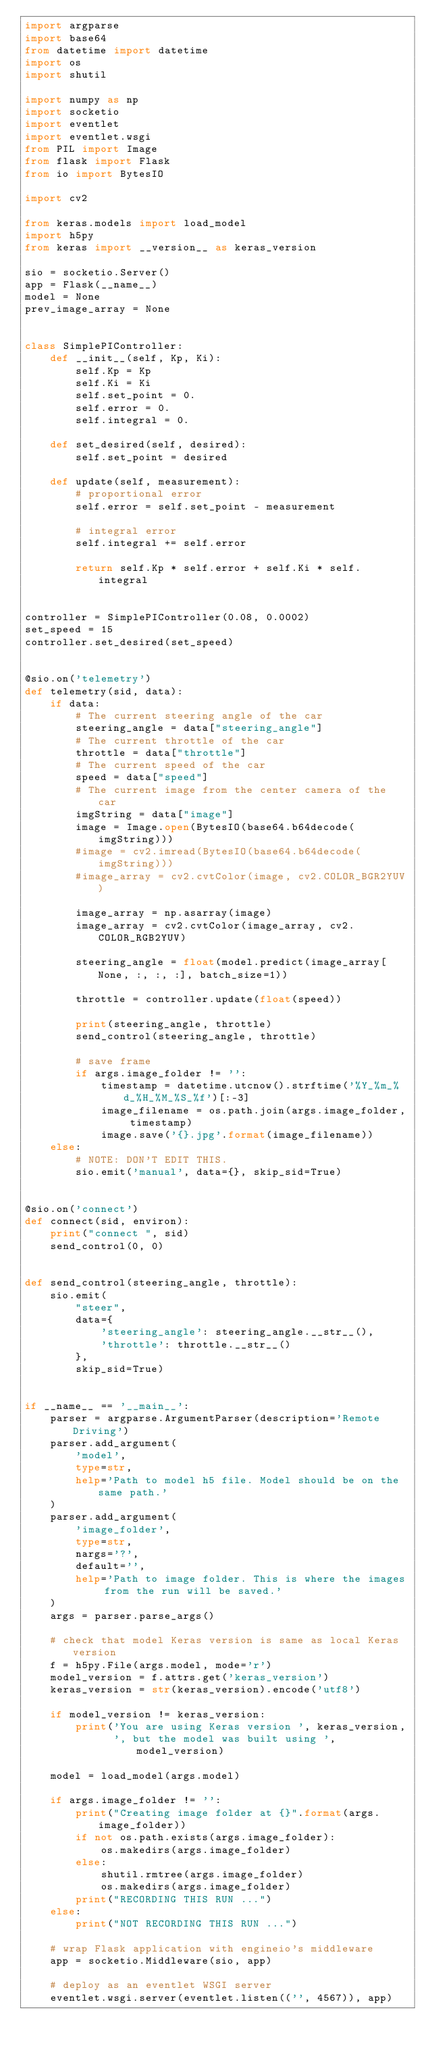<code> <loc_0><loc_0><loc_500><loc_500><_Python_>import argparse
import base64
from datetime import datetime
import os
import shutil

import numpy as np
import socketio
import eventlet
import eventlet.wsgi
from PIL import Image
from flask import Flask
from io import BytesIO

import cv2

from keras.models import load_model
import h5py
from keras import __version__ as keras_version

sio = socketio.Server()
app = Flask(__name__)
model = None
prev_image_array = None


class SimplePIController:
    def __init__(self, Kp, Ki):
        self.Kp = Kp
        self.Ki = Ki
        self.set_point = 0.
        self.error = 0.
        self.integral = 0.

    def set_desired(self, desired):
        self.set_point = desired

    def update(self, measurement):
        # proportional error
        self.error = self.set_point - measurement

        # integral error
        self.integral += self.error

        return self.Kp * self.error + self.Ki * self.integral


controller = SimplePIController(0.08, 0.0002)
set_speed = 15
controller.set_desired(set_speed)


@sio.on('telemetry')
def telemetry(sid, data):
    if data:
        # The current steering angle of the car
        steering_angle = data["steering_angle"]
        # The current throttle of the car
        throttle = data["throttle"]
        # The current speed of the car
        speed = data["speed"]
        # The current image from the center camera of the car
        imgString = data["image"]
        image = Image.open(BytesIO(base64.b64decode(imgString)))
        #image = cv2.imread(BytesIO(base64.b64decode(imgString)))
        #image_array = cv2.cvtColor(image, cv2.COLOR_BGR2YUV)

        image_array = np.asarray(image)
        image_array = cv2.cvtColor(image_array, cv2.COLOR_RGB2YUV)

        steering_angle = float(model.predict(image_array[None, :, :, :], batch_size=1))

        throttle = controller.update(float(speed))

        print(steering_angle, throttle)
        send_control(steering_angle, throttle)

        # save frame
        if args.image_folder != '':
            timestamp = datetime.utcnow().strftime('%Y_%m_%d_%H_%M_%S_%f')[:-3]
            image_filename = os.path.join(args.image_folder, timestamp)
            image.save('{}.jpg'.format(image_filename))
    else:
        # NOTE: DON'T EDIT THIS.
        sio.emit('manual', data={}, skip_sid=True)


@sio.on('connect')
def connect(sid, environ):
    print("connect ", sid)
    send_control(0, 0)


def send_control(steering_angle, throttle):
    sio.emit(
        "steer",
        data={
            'steering_angle': steering_angle.__str__(),
            'throttle': throttle.__str__()
        },
        skip_sid=True)


if __name__ == '__main__':
    parser = argparse.ArgumentParser(description='Remote Driving')
    parser.add_argument(
        'model',
        type=str,
        help='Path to model h5 file. Model should be on the same path.'
    )
    parser.add_argument(
        'image_folder',
        type=str,
        nargs='?',
        default='',
        help='Path to image folder. This is where the images from the run will be saved.'
    )
    args = parser.parse_args()

    # check that model Keras version is same as local Keras version
    f = h5py.File(args.model, mode='r')
    model_version = f.attrs.get('keras_version')
    keras_version = str(keras_version).encode('utf8')

    if model_version != keras_version:
        print('You are using Keras version ', keras_version,
              ', but the model was built using ', model_version)

    model = load_model(args.model)

    if args.image_folder != '':
        print("Creating image folder at {}".format(args.image_folder))
        if not os.path.exists(args.image_folder):
            os.makedirs(args.image_folder)
        else:
            shutil.rmtree(args.image_folder)
            os.makedirs(args.image_folder)
        print("RECORDING THIS RUN ...")
    else:
        print("NOT RECORDING THIS RUN ...")

    # wrap Flask application with engineio's middleware
    app = socketio.Middleware(sio, app)

    # deploy as an eventlet WSGI server
    eventlet.wsgi.server(eventlet.listen(('', 4567)), app)
</code> 